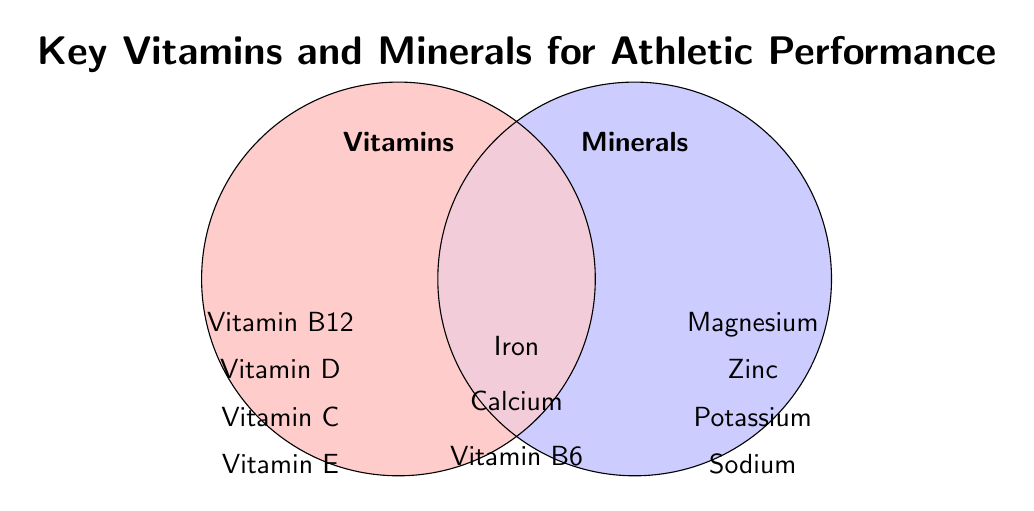What is the title of the Venn Diagram? The title is located at the top of the figure, in large text.
Answer: Key Vitamins and Minerals for Athletic Performance Which vitamins are listed specifically under the 'Vitamins' section? The vitamins listed are directly under the 'Vitamins' circle.
Answer: Vitamin B12, Vitamin D, Vitamin C, Vitamin E How many items are listed under the 'Minerals' section? Count all the items directly under the 'Minerals' circle.
Answer: 4 Which items are common between vitamins and minerals? Look at items located in the overlapping area of the two circles.
Answer: Iron, Calcium, Vitamin B6 Are there more exclusive vitamins or minerals listed? Compare the number of items under the 'Vitamins' and 'Minerals' sections, excluding the overlapping items.
Answer: More exclusive vitamins Which mineral is absent but all its other category items are present? Find the item under 'Minerals' that does not have a counterpart in 'Vitamins'.
Answer: Sodium Name three important nutrients for athletic performance that are both vitamins and minerals. Identify items in the overlapping section of the figure.
Answer: Iron, Calcium, Vitamin B6 List all the vitamins shown in the diagram. Combine the vitamins listed exclusively under 'Vitamins' and the common items in the overlapping section.
Answer: Vitamin B12, Vitamin D, Vitamin C, Vitamin E, Vitamin B6 Which nutrient is only found in the 'Minerals' section but starts with 'M'? Look specifically at the items under 'Minerals' and identify the one starting with 'M'.
Answer: Magnesium 